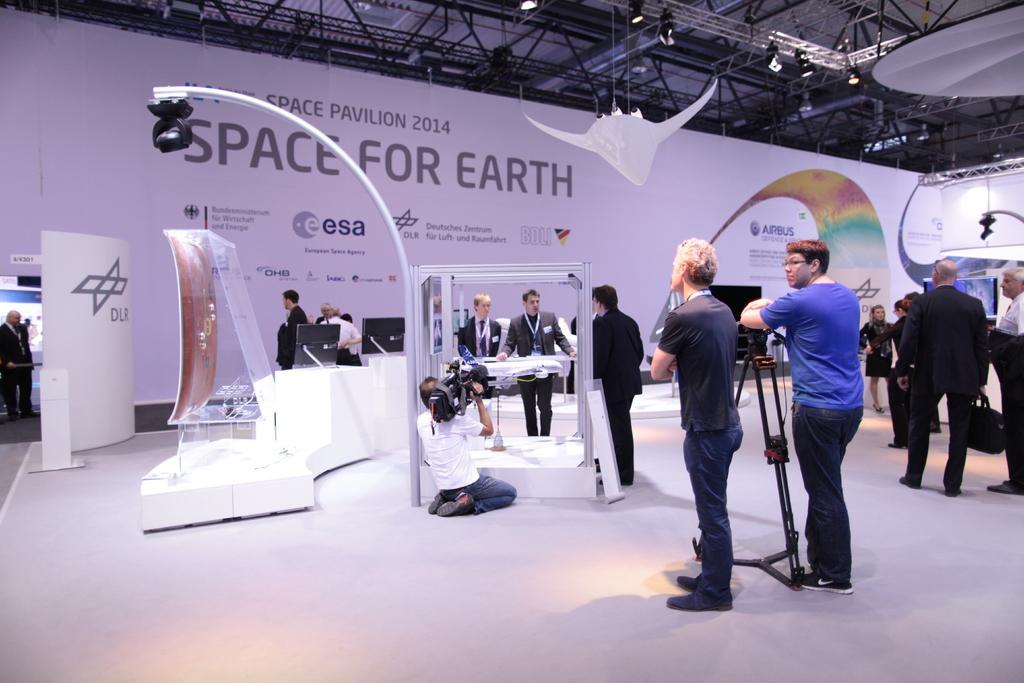In one or two sentences, can you explain what this image depicts? In this picture I can see group of people standing, there is a person holding a camera, there is a tripod stand, there are focus lights, lighting trusses, there are boards and some other objects. 